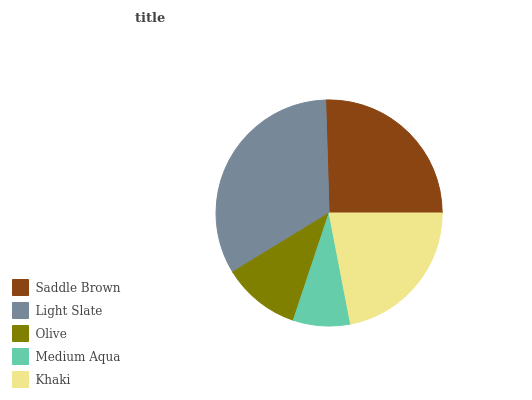Is Medium Aqua the minimum?
Answer yes or no. Yes. Is Light Slate the maximum?
Answer yes or no. Yes. Is Olive the minimum?
Answer yes or no. No. Is Olive the maximum?
Answer yes or no. No. Is Light Slate greater than Olive?
Answer yes or no. Yes. Is Olive less than Light Slate?
Answer yes or no. Yes. Is Olive greater than Light Slate?
Answer yes or no. No. Is Light Slate less than Olive?
Answer yes or no. No. Is Khaki the high median?
Answer yes or no. Yes. Is Khaki the low median?
Answer yes or no. Yes. Is Light Slate the high median?
Answer yes or no. No. Is Light Slate the low median?
Answer yes or no. No. 